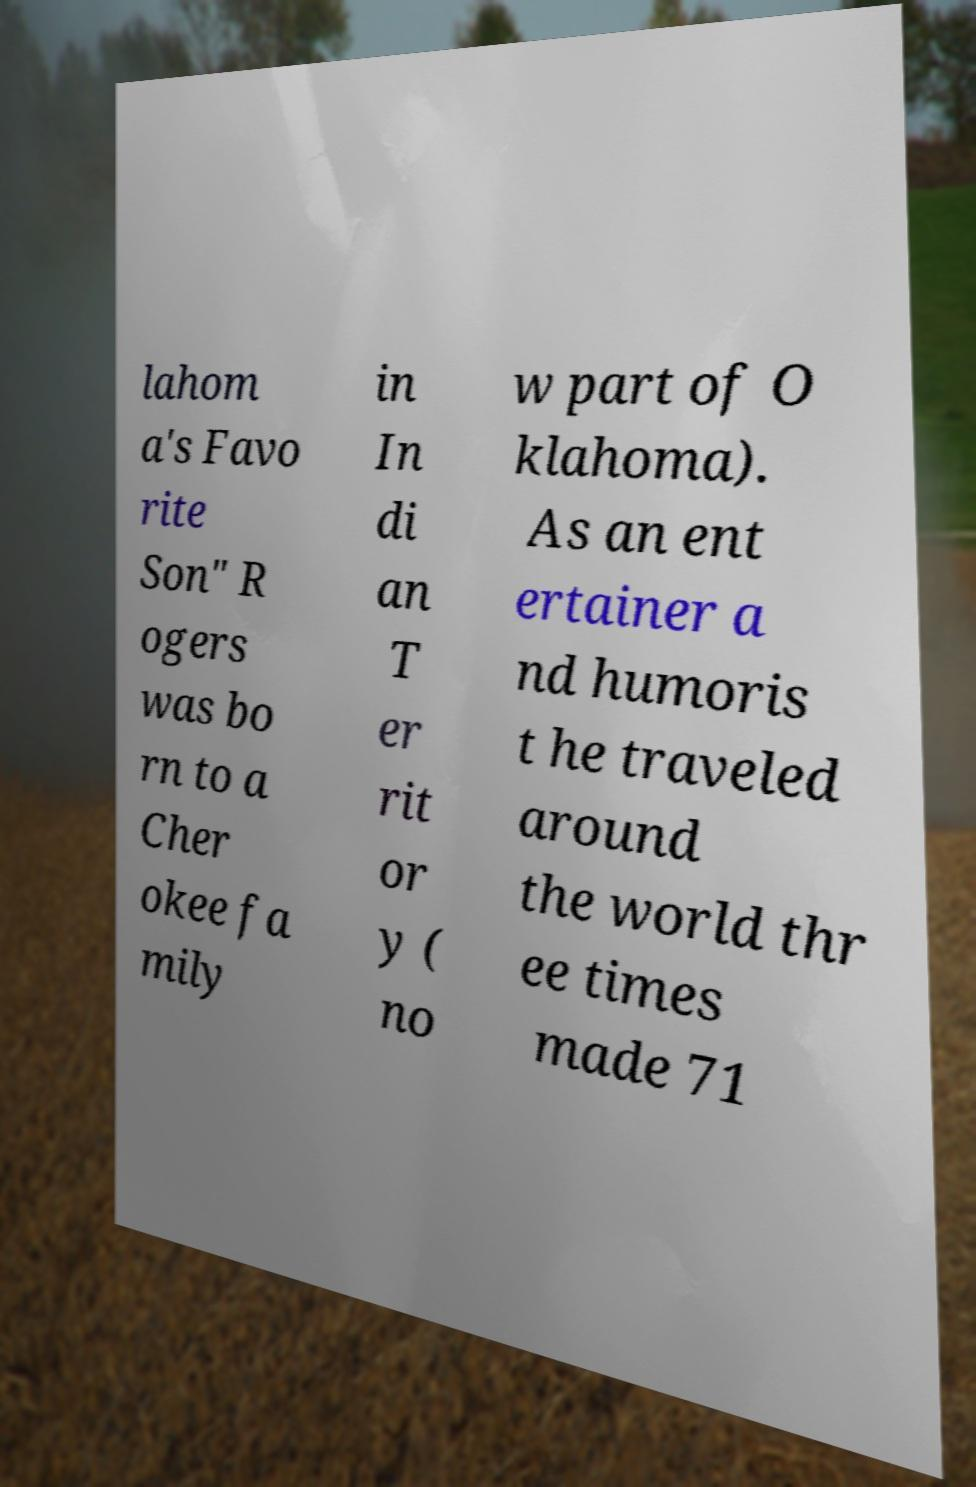Can you read and provide the text displayed in the image?This photo seems to have some interesting text. Can you extract and type it out for me? lahom a's Favo rite Son" R ogers was bo rn to a Cher okee fa mily in In di an T er rit or y ( no w part of O klahoma). As an ent ertainer a nd humoris t he traveled around the world thr ee times made 71 